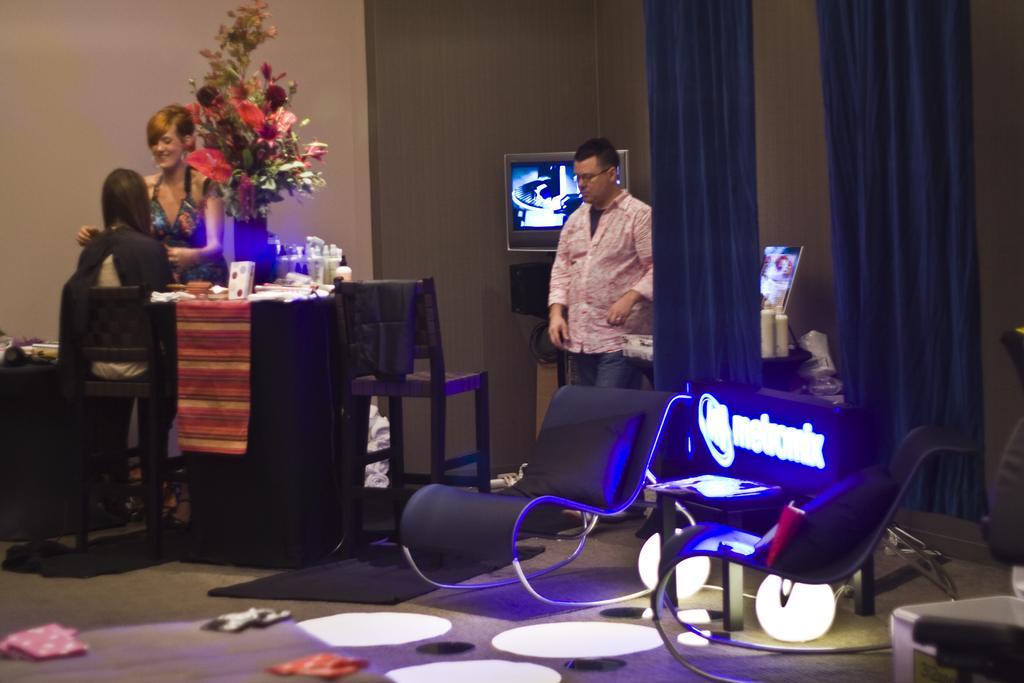How would you summarize this image in a sentence or two? This is a room where we can see three people and the chair and the table and on the table we can see some flowers, liquids and two screens and two lamps. 